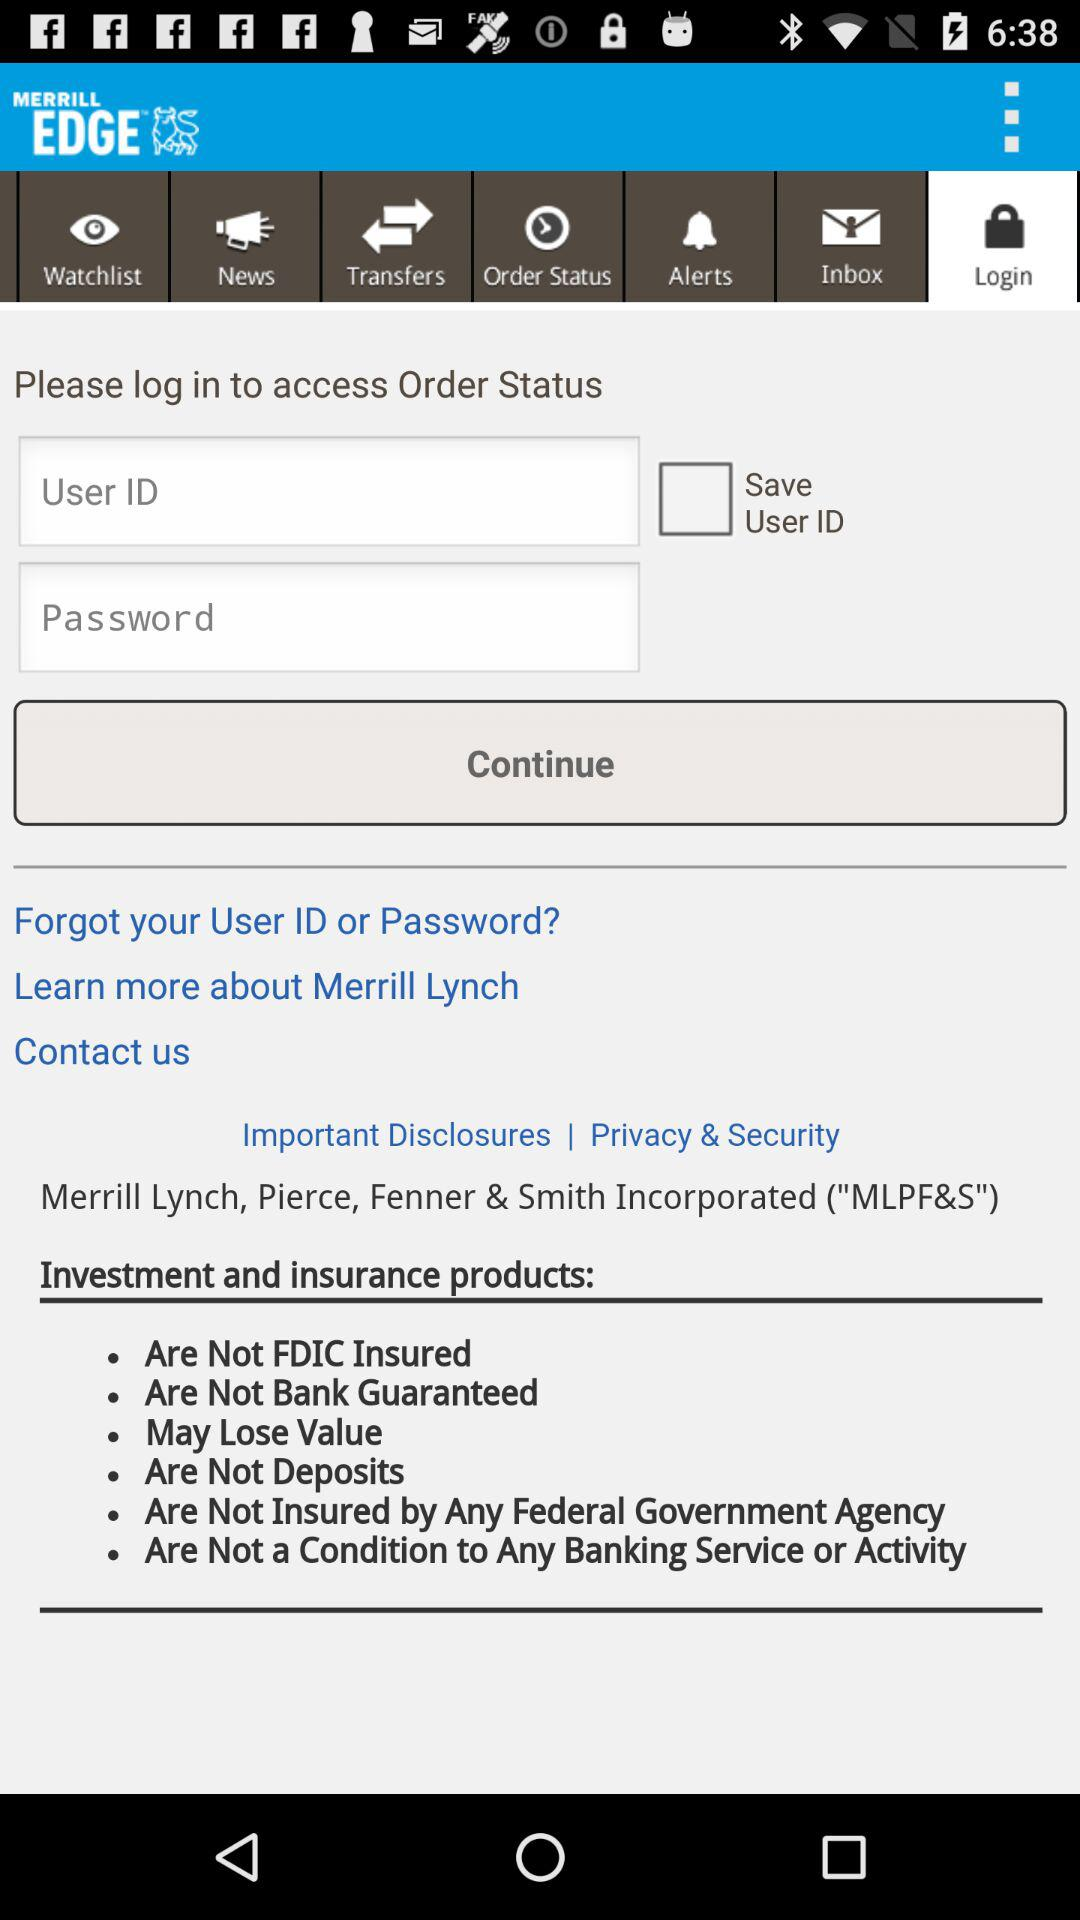How many text input fields are there on this screen?
Answer the question using a single word or phrase. 2 